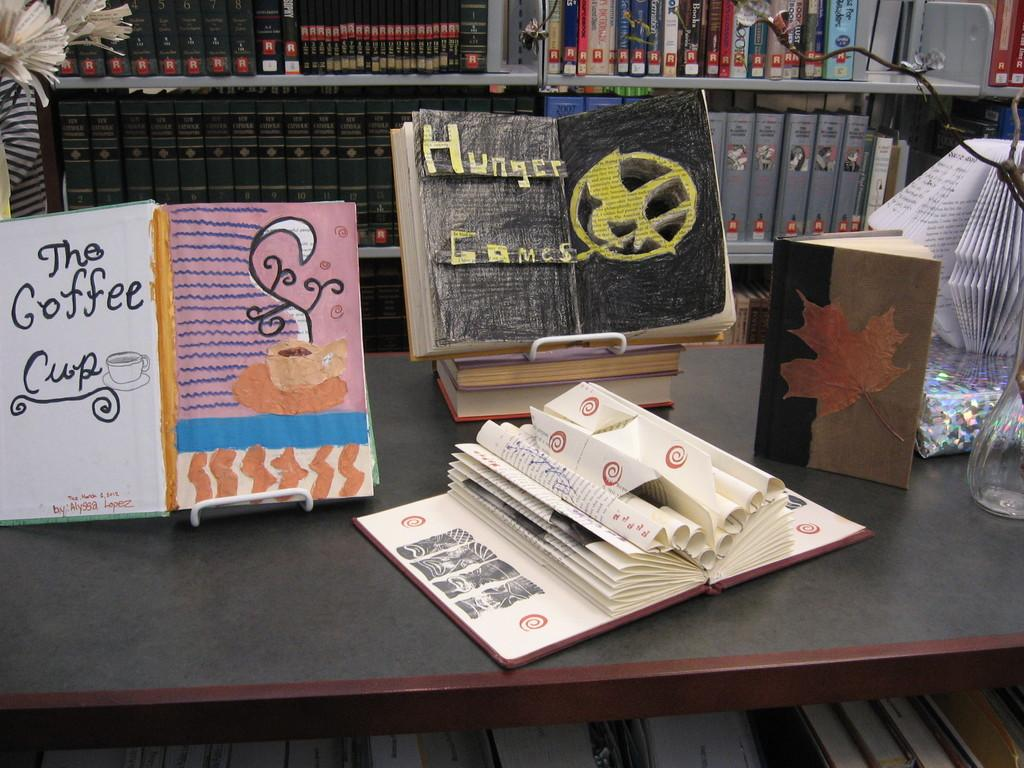<image>
Give a short and clear explanation of the subsequent image. The art on the left is for the story called Coffee Cup 